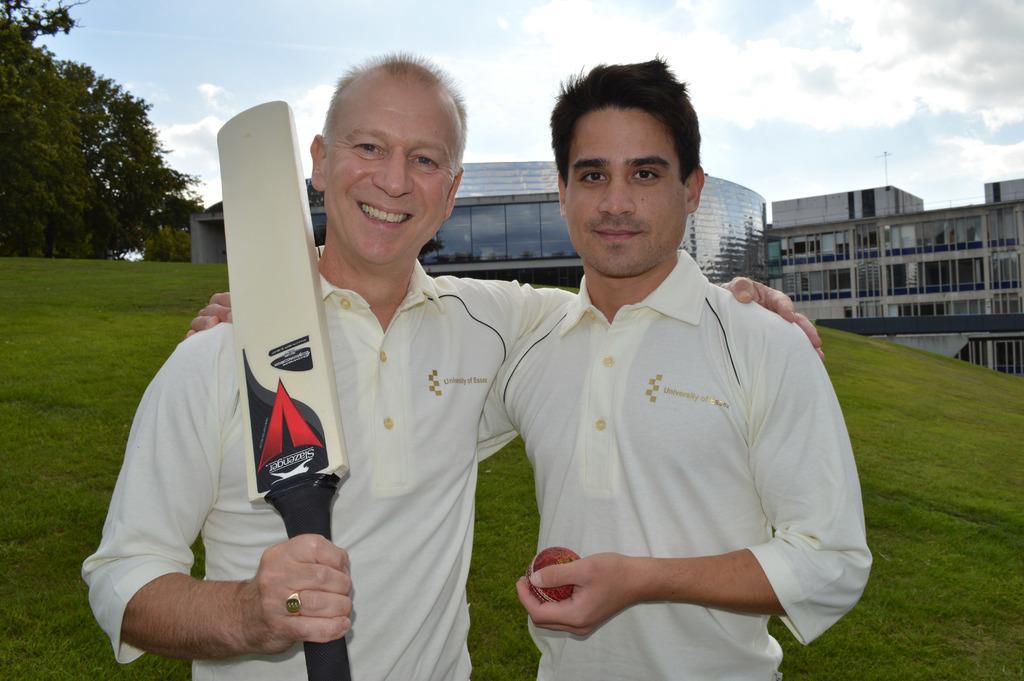Describe this image in one or two sentences. In the center of the image there are two people. The man standing on the right is holding a ball in his hand and a man on the left is smiling and holding a bat in his hand. In the background there are buildings, trees and sky. 